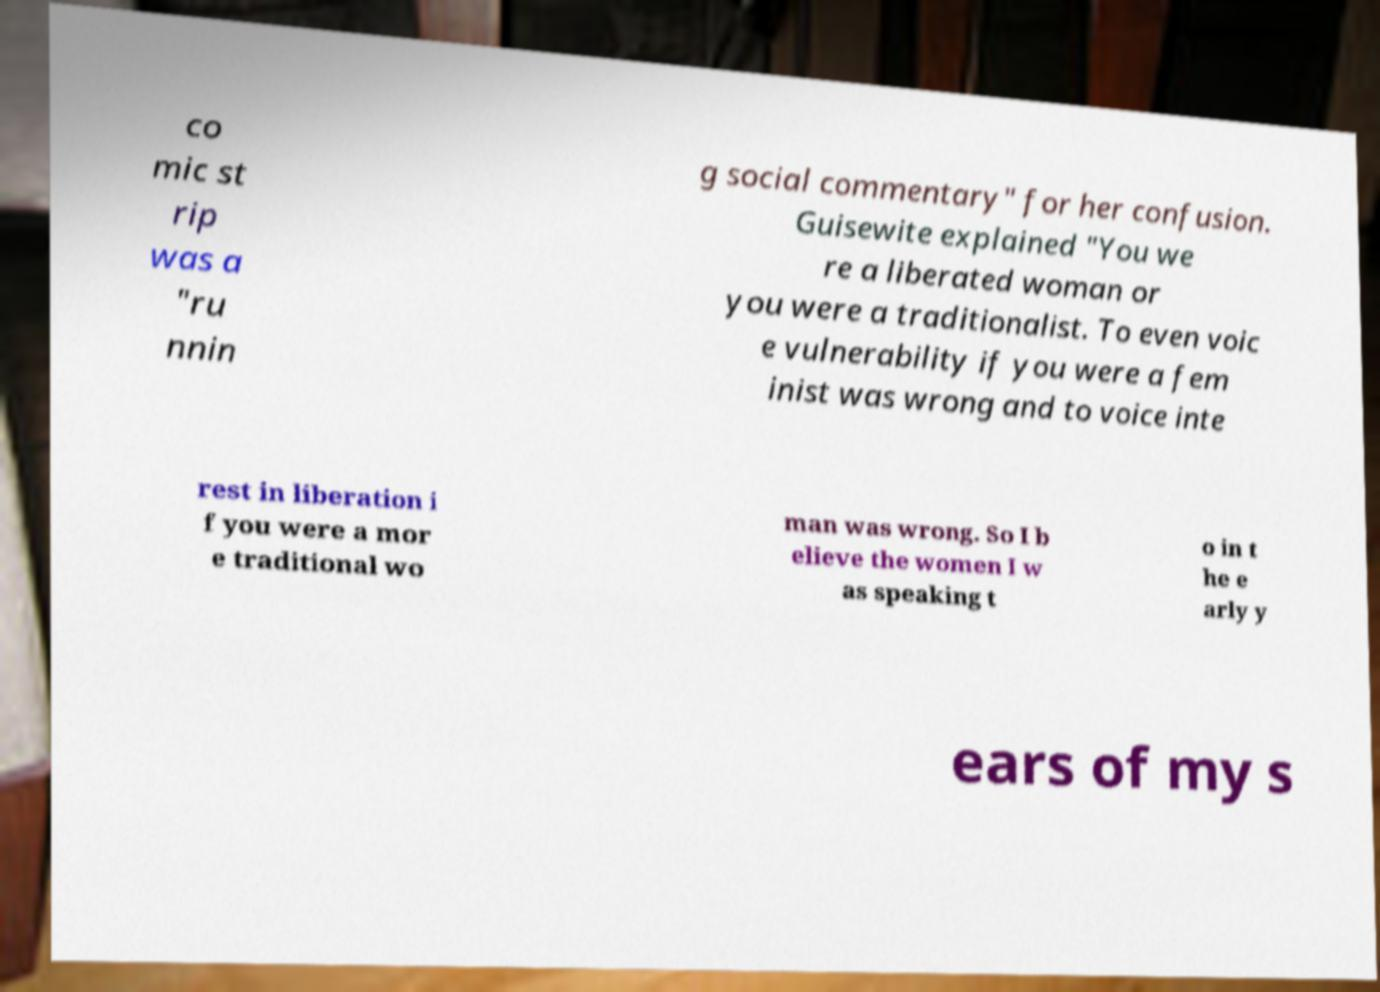I need the written content from this picture converted into text. Can you do that? co mic st rip was a "ru nnin g social commentary" for her confusion. Guisewite explained "You we re a liberated woman or you were a traditionalist. To even voic e vulnerability if you were a fem inist was wrong and to voice inte rest in liberation i f you were a mor e traditional wo man was wrong. So I b elieve the women I w as speaking t o in t he e arly y ears of my s 